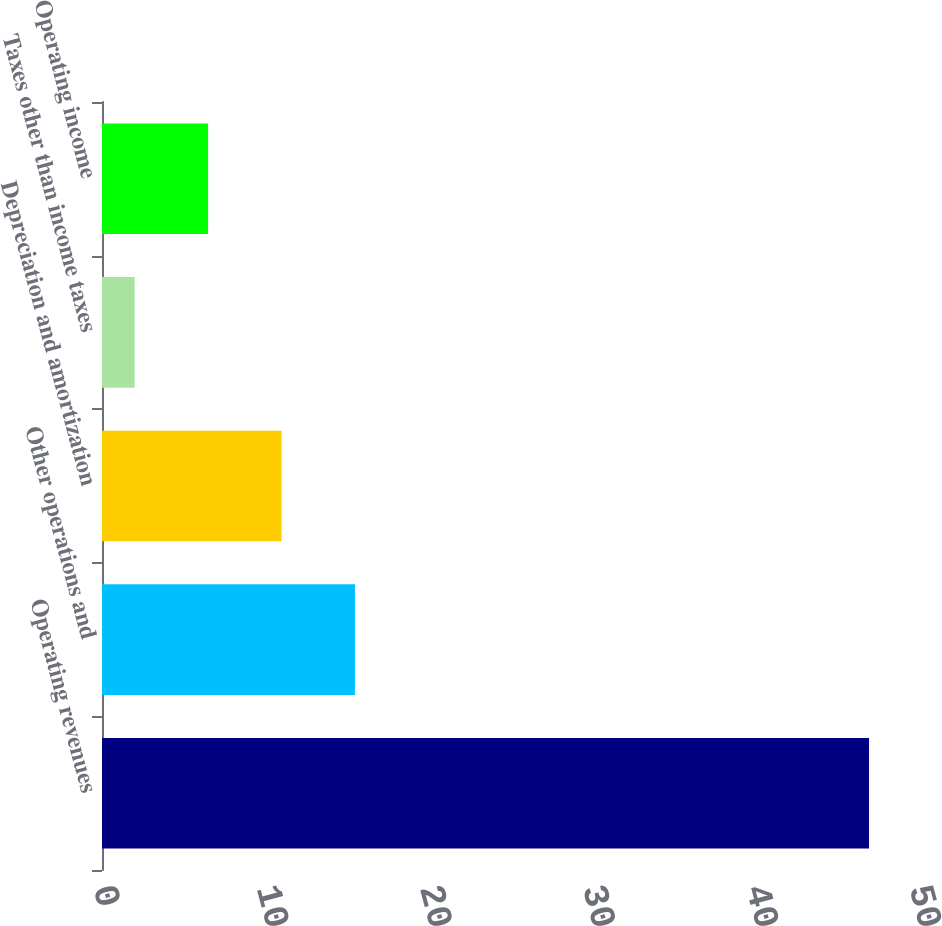Convert chart. <chart><loc_0><loc_0><loc_500><loc_500><bar_chart><fcel>Operating revenues<fcel>Other operations and<fcel>Depreciation and amortization<fcel>Taxes other than income taxes<fcel>Operating income<nl><fcel>47<fcel>15.5<fcel>11<fcel>2<fcel>6.5<nl></chart> 